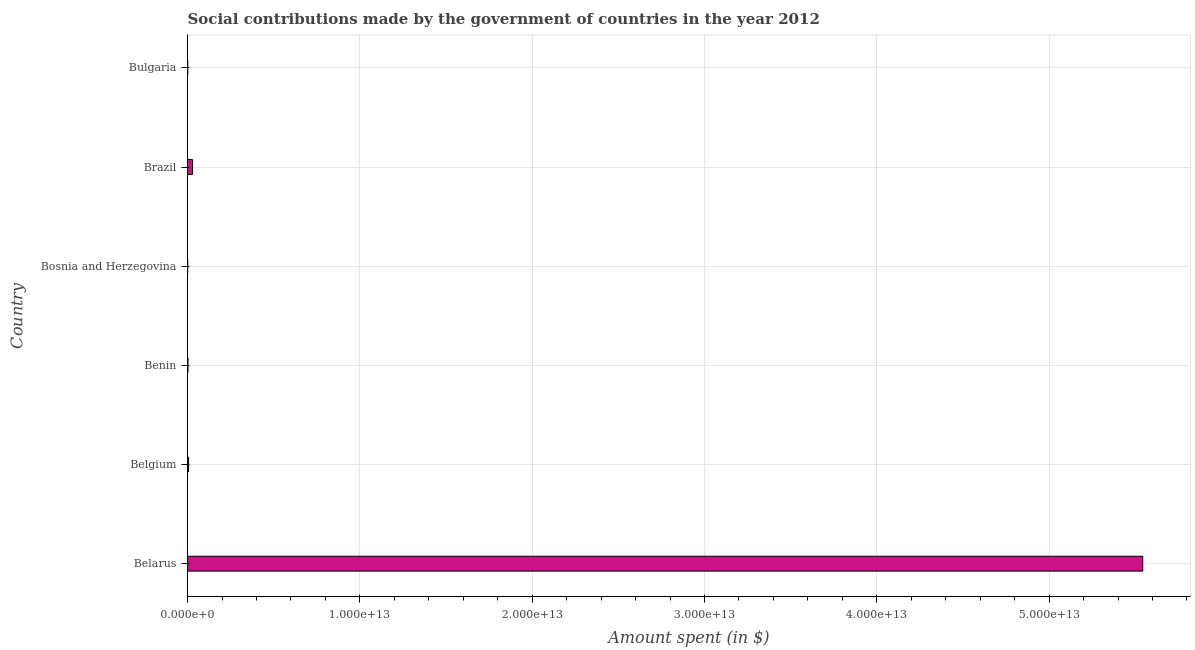Does the graph contain any zero values?
Your answer should be compact. No. Does the graph contain grids?
Your answer should be very brief. Yes. What is the title of the graph?
Provide a succinct answer. Social contributions made by the government of countries in the year 2012. What is the label or title of the X-axis?
Keep it short and to the point. Amount spent (in $). What is the label or title of the Y-axis?
Give a very brief answer. Country. What is the amount spent in making social contributions in Bosnia and Herzegovina?
Provide a succinct answer. 4.05e+09. Across all countries, what is the maximum amount spent in making social contributions?
Your response must be concise. 5.54e+13. Across all countries, what is the minimum amount spent in making social contributions?
Offer a terse response. 4.05e+09. In which country was the amount spent in making social contributions maximum?
Provide a succinct answer. Belarus. In which country was the amount spent in making social contributions minimum?
Provide a short and direct response. Bosnia and Herzegovina. What is the sum of the amount spent in making social contributions?
Give a very brief answer. 5.58e+13. What is the difference between the amount spent in making social contributions in Benin and Brazil?
Offer a very short reply. -2.69e+11. What is the average amount spent in making social contributions per country?
Provide a short and direct response. 9.30e+12. What is the median amount spent in making social contributions?
Offer a very short reply. 3.89e+1. What is the ratio of the amount spent in making social contributions in Belgium to that in Bulgaria?
Ensure brevity in your answer.  10.14. What is the difference between the highest and the second highest amount spent in making social contributions?
Offer a terse response. 5.51e+13. Is the sum of the amount spent in making social contributions in Belarus and Bosnia and Herzegovina greater than the maximum amount spent in making social contributions across all countries?
Ensure brevity in your answer.  Yes. What is the difference between the highest and the lowest amount spent in making social contributions?
Your response must be concise. 5.54e+13. In how many countries, is the amount spent in making social contributions greater than the average amount spent in making social contributions taken over all countries?
Provide a short and direct response. 1. How many bars are there?
Ensure brevity in your answer.  6. Are all the bars in the graph horizontal?
Your answer should be very brief. Yes. How many countries are there in the graph?
Keep it short and to the point. 6. What is the difference between two consecutive major ticks on the X-axis?
Provide a short and direct response. 1.00e+13. What is the Amount spent (in $) of Belarus?
Make the answer very short. 5.54e+13. What is the Amount spent (in $) in Belgium?
Provide a succinct answer. 5.70e+1. What is the Amount spent (in $) in Benin?
Give a very brief answer. 2.07e+1. What is the Amount spent (in $) in Bosnia and Herzegovina?
Your response must be concise. 4.05e+09. What is the Amount spent (in $) of Brazil?
Your response must be concise. 2.89e+11. What is the Amount spent (in $) in Bulgaria?
Your answer should be very brief. 5.62e+09. What is the difference between the Amount spent (in $) in Belarus and Belgium?
Provide a short and direct response. 5.54e+13. What is the difference between the Amount spent (in $) in Belarus and Benin?
Ensure brevity in your answer.  5.54e+13. What is the difference between the Amount spent (in $) in Belarus and Bosnia and Herzegovina?
Give a very brief answer. 5.54e+13. What is the difference between the Amount spent (in $) in Belarus and Brazil?
Offer a terse response. 5.51e+13. What is the difference between the Amount spent (in $) in Belarus and Bulgaria?
Ensure brevity in your answer.  5.54e+13. What is the difference between the Amount spent (in $) in Belgium and Benin?
Ensure brevity in your answer.  3.63e+1. What is the difference between the Amount spent (in $) in Belgium and Bosnia and Herzegovina?
Your response must be concise. 5.30e+1. What is the difference between the Amount spent (in $) in Belgium and Brazil?
Keep it short and to the point. -2.32e+11. What is the difference between the Amount spent (in $) in Belgium and Bulgaria?
Provide a succinct answer. 5.14e+1. What is the difference between the Amount spent (in $) in Benin and Bosnia and Herzegovina?
Offer a very short reply. 1.67e+1. What is the difference between the Amount spent (in $) in Benin and Brazil?
Your answer should be very brief. -2.69e+11. What is the difference between the Amount spent (in $) in Benin and Bulgaria?
Offer a very short reply. 1.51e+1. What is the difference between the Amount spent (in $) in Bosnia and Herzegovina and Brazil?
Your response must be concise. -2.85e+11. What is the difference between the Amount spent (in $) in Bosnia and Herzegovina and Bulgaria?
Keep it short and to the point. -1.58e+09. What is the difference between the Amount spent (in $) in Brazil and Bulgaria?
Offer a terse response. 2.84e+11. What is the ratio of the Amount spent (in $) in Belarus to that in Belgium?
Keep it short and to the point. 972.14. What is the ratio of the Amount spent (in $) in Belarus to that in Benin?
Ensure brevity in your answer.  2675.72. What is the ratio of the Amount spent (in $) in Belarus to that in Bosnia and Herzegovina?
Ensure brevity in your answer.  1.37e+04. What is the ratio of the Amount spent (in $) in Belarus to that in Brazil?
Provide a succinct answer. 191.51. What is the ratio of the Amount spent (in $) in Belarus to that in Bulgaria?
Ensure brevity in your answer.  9859.57. What is the ratio of the Amount spent (in $) in Belgium to that in Benin?
Provide a short and direct response. 2.75. What is the ratio of the Amount spent (in $) in Belgium to that in Bosnia and Herzegovina?
Ensure brevity in your answer.  14.09. What is the ratio of the Amount spent (in $) in Belgium to that in Brazil?
Offer a terse response. 0.2. What is the ratio of the Amount spent (in $) in Belgium to that in Bulgaria?
Your answer should be compact. 10.14. What is the ratio of the Amount spent (in $) in Benin to that in Bosnia and Herzegovina?
Give a very brief answer. 5.12. What is the ratio of the Amount spent (in $) in Benin to that in Brazil?
Make the answer very short. 0.07. What is the ratio of the Amount spent (in $) in Benin to that in Bulgaria?
Provide a succinct answer. 3.69. What is the ratio of the Amount spent (in $) in Bosnia and Herzegovina to that in Brazil?
Give a very brief answer. 0.01. What is the ratio of the Amount spent (in $) in Bosnia and Herzegovina to that in Bulgaria?
Your answer should be compact. 0.72. What is the ratio of the Amount spent (in $) in Brazil to that in Bulgaria?
Your answer should be very brief. 51.48. 